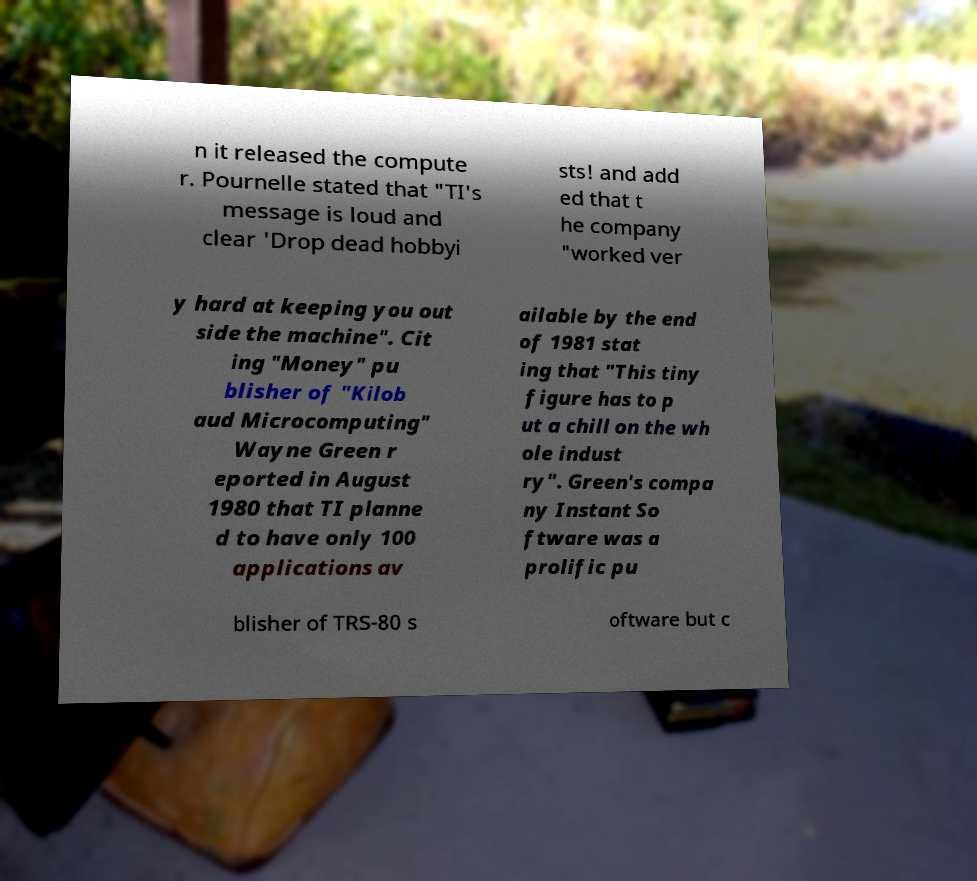Can you accurately transcribe the text from the provided image for me? n it released the compute r. Pournelle stated that "TI's message is loud and clear 'Drop dead hobbyi sts! and add ed that t he company "worked ver y hard at keeping you out side the machine". Cit ing "Money" pu blisher of "Kilob aud Microcomputing" Wayne Green r eported in August 1980 that TI planne d to have only 100 applications av ailable by the end of 1981 stat ing that "This tiny figure has to p ut a chill on the wh ole indust ry". Green's compa ny Instant So ftware was a prolific pu blisher of TRS-80 s oftware but c 